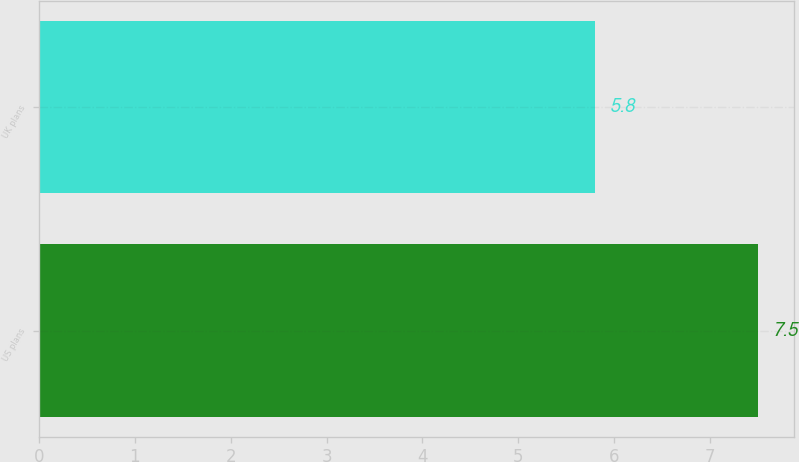<chart> <loc_0><loc_0><loc_500><loc_500><bar_chart><fcel>US plans<fcel>UK plans<nl><fcel>7.5<fcel>5.8<nl></chart> 